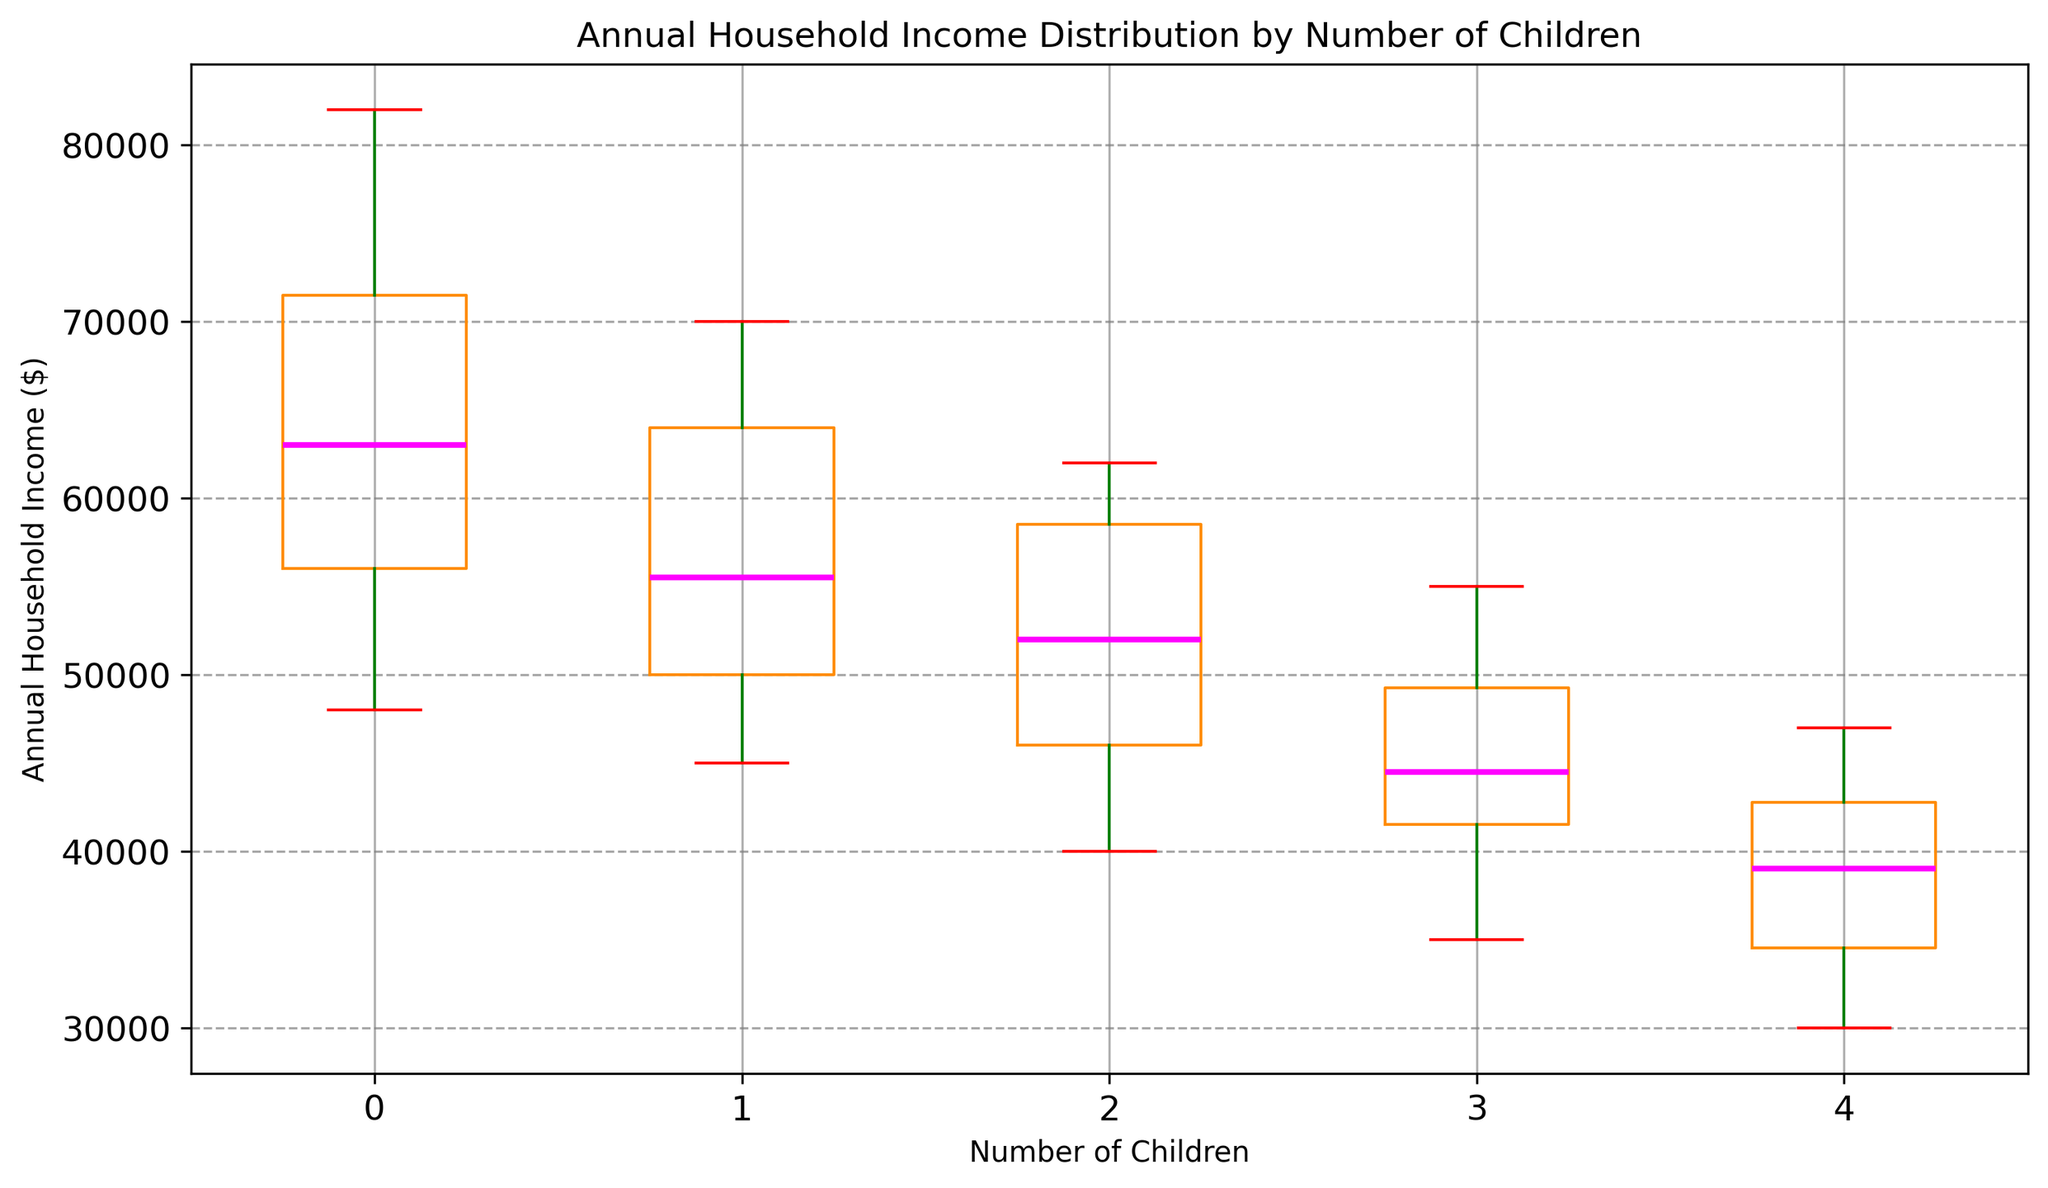What is the median annual household income for families with 2 children? To determine the median, look at the middle value in the sorted list of annual incomes for families with 2 children. The values are: [40000, 42000, 45000, 49000, 53000, 51000, 57000, 60000, 62000, 59000]. The median is the average of the 5th and 6th values (51000 and 53000).
Answer: 51500 Which group has the highest median annual household income? Compare the median lines of the box plots for each number of children. The group with 0 children has the highest median income.
Answer: Families with 0 children How does the interquartile range (IQR) for families with 3 children compare to that of families with 1 child? The IQR is the range between the first quartile (Q1) and third quartile (Q3). For families with 3 children, Q1 is around 41000 and Q3 around 45000, giving an IQR of 45000 - 41000 = 4000. For families with 1 child, Q1 is around 49000 and Q3 around 61000, making the IQR 61000 - 49000 = 12000. So, the IQR for families with 1 child is greater.
Answer: Families with 1 child have a greater IQR Which group has the lowest maximum annual household income? The maximum income is indicated by the top whisker of each box plot. The group with 1 child has the lowest maximum income.
Answer: Families with 1 child What is the difference between the median incomes of families with 0 children and families with 4 children? The median for families with 0 children is around 64000, and for families with 4 children, it is around 42000. The difference = 64000 - 42000 = 22000.
Answer: 22000 For families with 0 children, what is the range of annual household incomes from the lowest to the highest value? Examine the whisker ends of the box plot for families with 0 children. The minimum is around 48000 and the maximum is around 82000. The range = 82000 - 48000 = 34000.
Answer: 34000 Which group has the widest range of annual household incomes? Compare the distance between the minimum and maximum values across all box plots. The group with 0 children shows the widest range.
Answer: Families with 0 children How many groups have a median income above 50000? Look at the median lines (magenta) of the box plots. Groups with 0 children and 2 children have median incomes above 50000.
Answer: 2 groups Does any group have an outlier income, and if so, which color indicates the outliers? Look for any points outside the whiskers of the box plots. The outliers are indicated by blue dots.
Answer: Yes, blue 